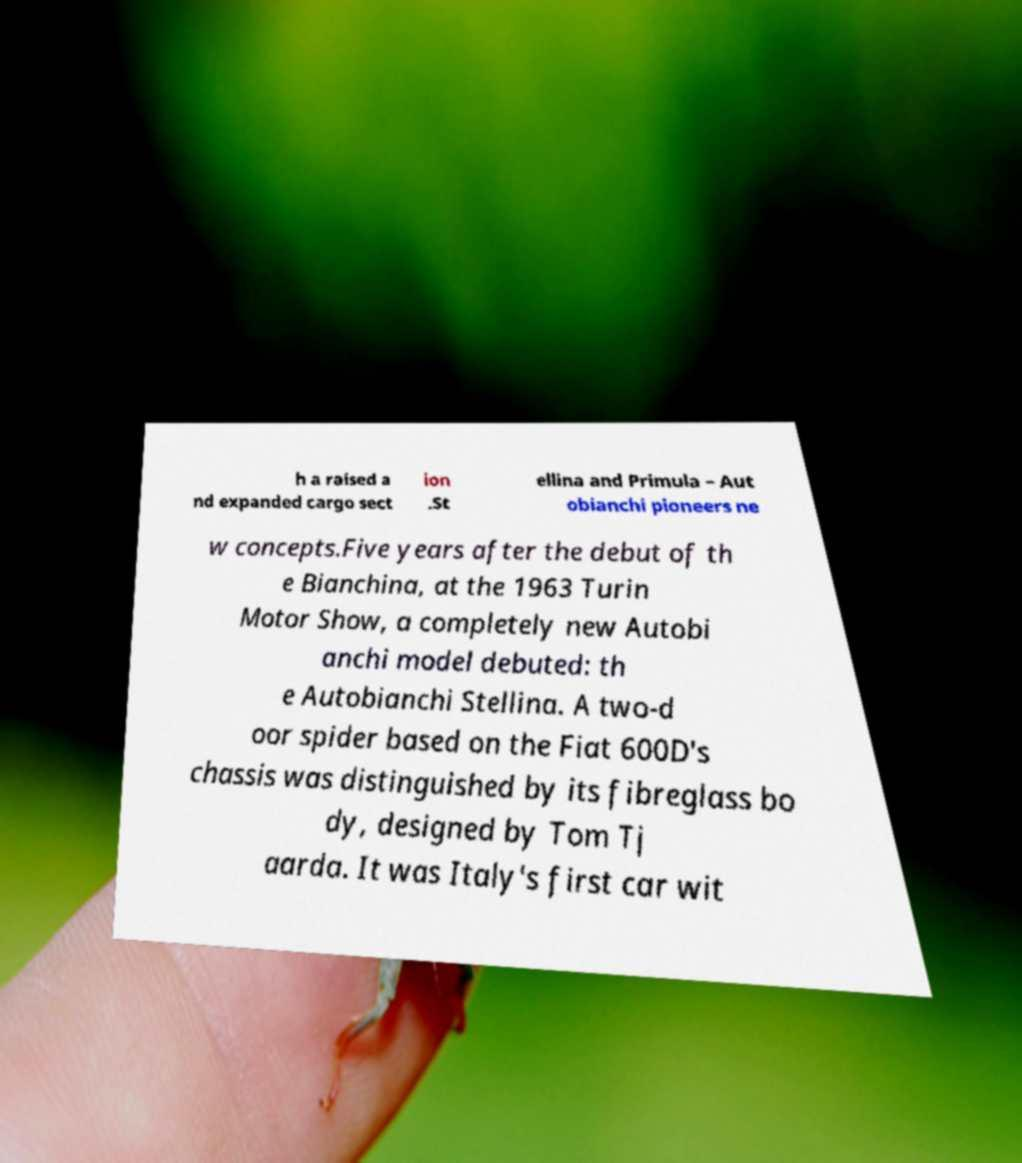Can you read and provide the text displayed in the image?This photo seems to have some interesting text. Can you extract and type it out for me? h a raised a nd expanded cargo sect ion .St ellina and Primula – Aut obianchi pioneers ne w concepts.Five years after the debut of th e Bianchina, at the 1963 Turin Motor Show, a completely new Autobi anchi model debuted: th e Autobianchi Stellina. A two-d oor spider based on the Fiat 600D's chassis was distinguished by its fibreglass bo dy, designed by Tom Tj aarda. It was Italy's first car wit 